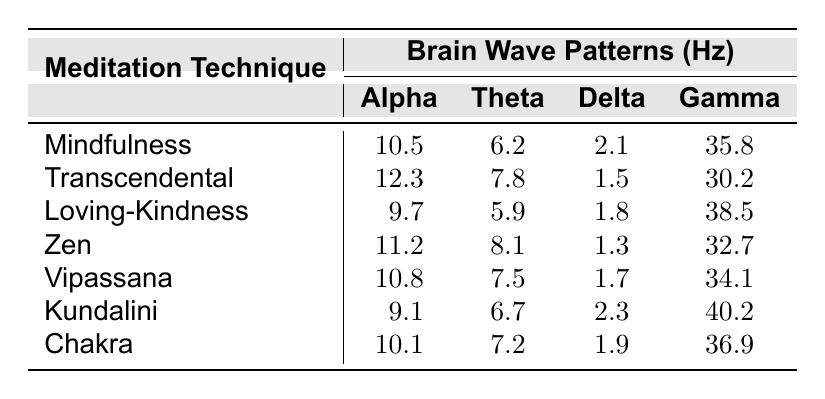What is the Alpha brain wave value for the Loving-Kindness technique? According to the table, the Alpha value for the Loving-Kindness technique is directly provided as 9.7.
Answer: 9.7 Which meditation technique has the highest Gamma brain wave value? The table lists the Gamma values for each technique, with Kundalini having the highest value at 40.2.
Answer: Kundalini What is the difference in Theta values between Transcendental and Zen techniques? The Theta value for Transcendental is 7.8, and for Zen, it is 8.1. The difference is calculated as 8.1 - 7.8 = 0.3.
Answer: 0.3 Is the Delta brain wave value for the Zen technique greater than that for the Vipassana technique? In the table, the Delta value for Zen is 1.3, and for Vipassana, it is 1.7. Since 1.3 is less than 1.7, the statement is false.
Answer: No What is the average Alpha brain wave value across all techniques? The Alpha values are 10.5, 12.3, 9.7, 11.2, 10.8, 9.1, and 10.1. Adding these gives 73.7, and dividing by 7 (the number of techniques) results in an average of approximately 10.53.
Answer: 10.53 Which meditation technique has the lowest Theta brain wave value? The Theta values listed are 6.2, 7.8, 5.9, 8.1, 7.5, 6.7, and 7.2. The lowest value is 5.9 for the Loving-Kindness technique.
Answer: Loving-Kindness What is the sum of Delta values for Mindfulness and Chakra techniques? The Delta value for Mindfulness is 2.1 and for Chakra is 1.9. Adding these two gives 2.1 + 1.9 = 4.0.
Answer: 4.0 How many techniques have an Alpha value greater than 10? The Alpha values are 10.5, 12.3, 9.7, 11.2, 10.8, 9.1, and 10.1. The techniques with Alpha values greater than 10 are Mindfulness, Transcendental, Zen, Vipassana, and Chakra, totaling 5 techniques.
Answer: 5 What is the maximum Theta value, and which technique corresponds to it? The maximum Theta value listed is 8.1, corresponding to the Zen technique.
Answer: 8.1, Zen Calculate the total of Gamma values for all meditation techniques. The Gamma values are 35.8, 30.2, 38.5, 32.7, 34.1, 40.2, and 36.9. Adding them gives a total of 308.4.
Answer: 308.4 